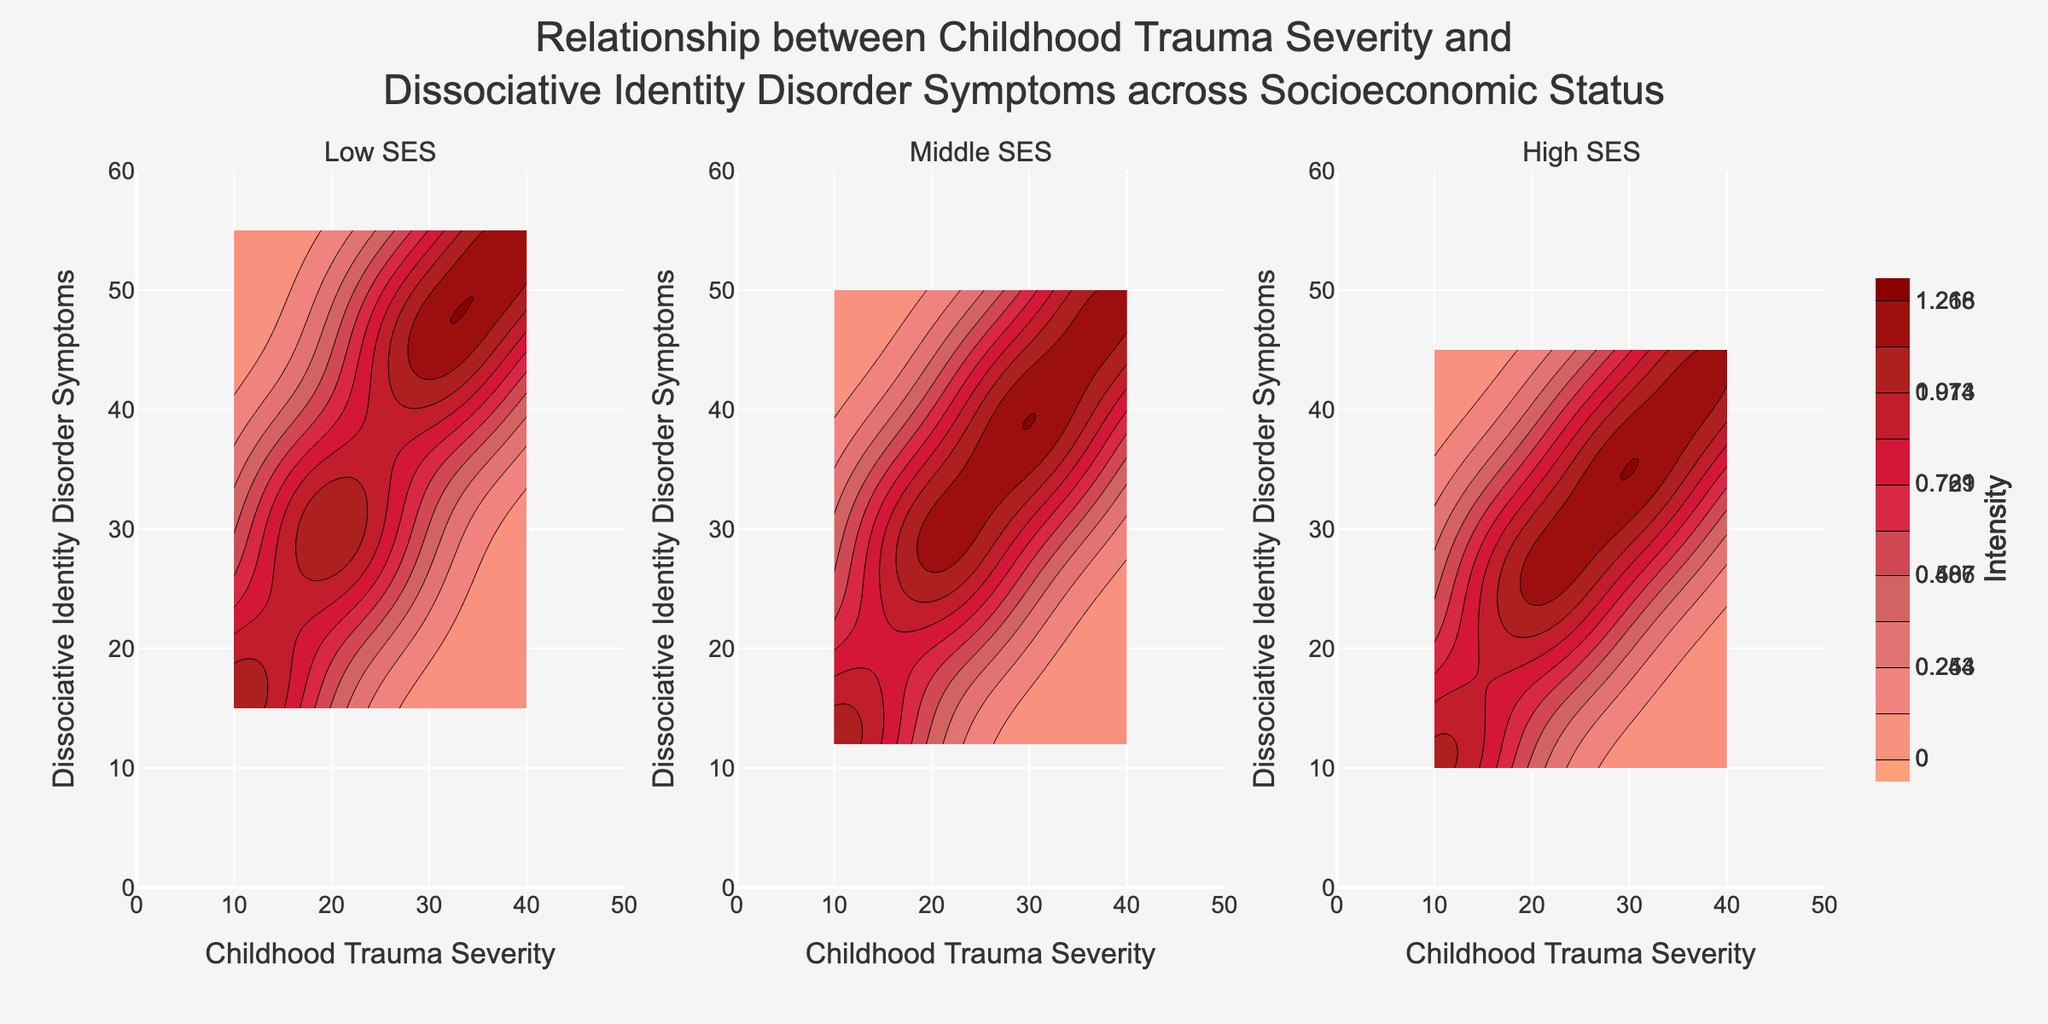What's the title of the figure? The title can be found at the top of the figure, centered and written in bold text, usually summarizing the main topic of the plot.
Answer: Relationship between Childhood Trauma Severity and Dissociative Identity Disorder Symptoms across Socioeconomic Status What are the labels on the x-axis and y-axis? The x-axis label is at the bottom horizontally, and the y-axis label is vertically along the left side.
Answer: Childhood Trauma Severity and Dissociative Identity Disorder Symptoms How many subplots are presented in the figure? The figure contains a row of horizontally aligned subplots, each labeled individually. Count these subplots.
Answer: Three What does the color gradient represent in the contour plots? The color gradient reflects varying intensities of data density, usually indicated by a color scale bar. The deeper colors generally indicate higher intensities.
Answer: Intensity Does the symptom severity increase with trauma severity in the High SES group? By observing the upward trend along the contour lines in the High SES subplot, one can determine if there's an increase.
Answer: Yes Which socioeconomic status shows the highest intensity of symptoms for moderate trauma severity (around 30)? Identify the subplot with the deepest color (indicating highest intensity) around the 30 mark on the x-axis.
Answer: Low SES How does the intensity of symptoms in Low SES compare to High SES for low trauma severity (around 10)? Compare the color depths at the 10 mark on the Childhood Trauma Severity axis in both Low SES and High SES subplots.
Answer: Higher in Low SES At what childhood trauma severity do Middle and High SES groups show similar symptom intensities? Find the childhood trauma severity value where the color depths for Middle and High SES are most similar.
Answer: Around 20 What range of symptom severity is covered in the High SES subplot? Look at the limits of the y-axis in the High SES subplot to find the range.
Answer: 0 to 60 What does the color bar on the right side indicate? The color bar illustrates how colors correspond to different intensity levels, typically used in contour plots to show density or frequency.
Answer: Intensity levels 